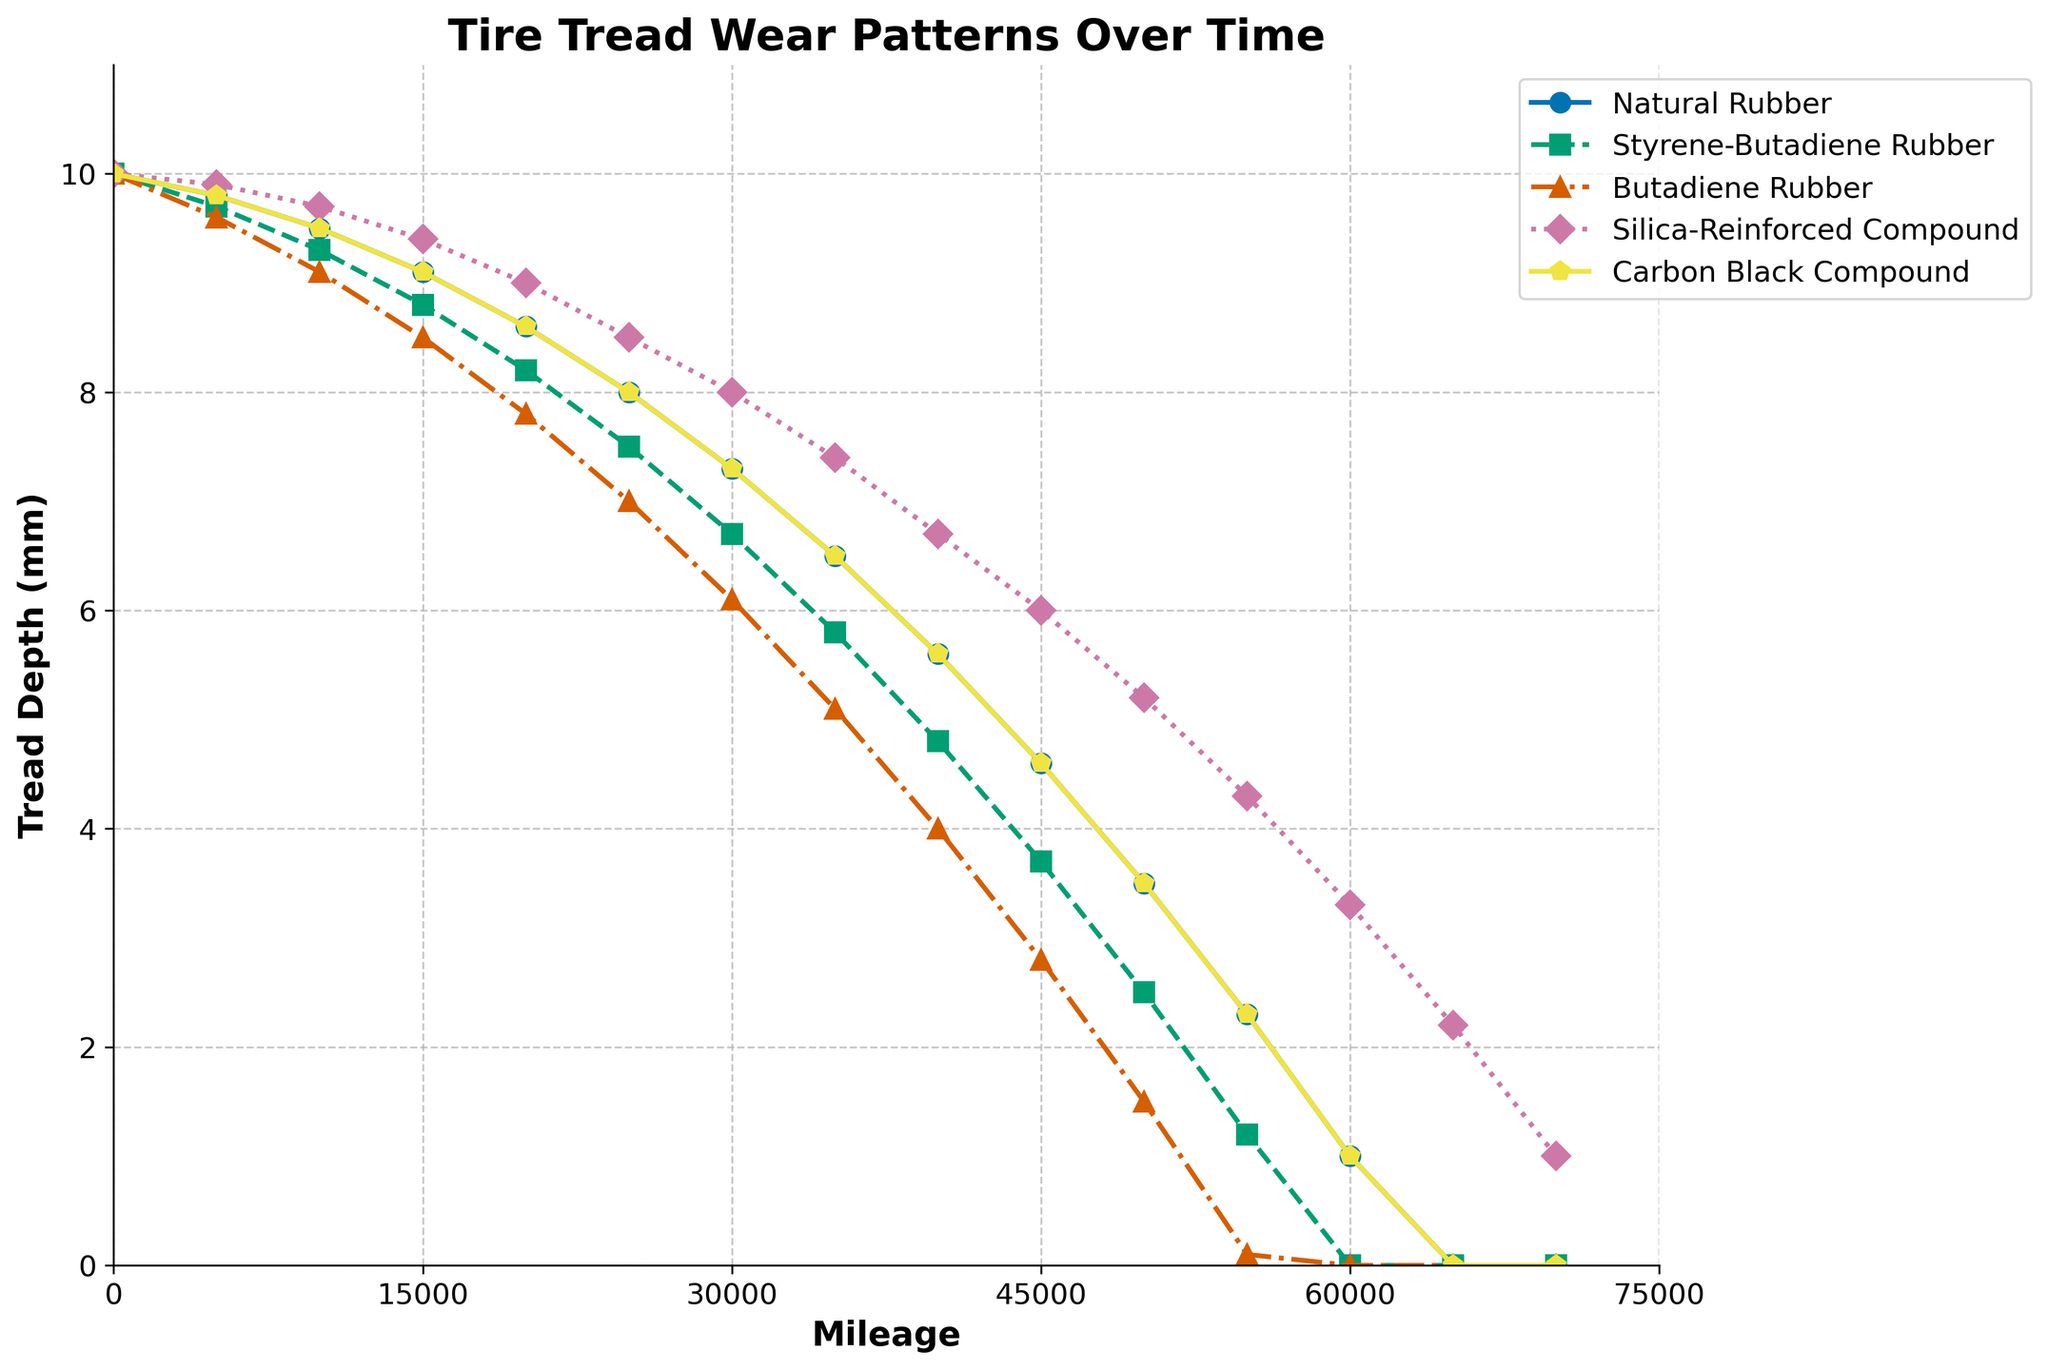Which tire compound retains the most tread depth after 50,000 miles? The tire compound with the most tread depth at 50,000 miles is the one with the highest vertical position at this mileage on the graph. Silica-Reinforced Compound has a tread depth of 5.2 mm, which is higher than all other compounds.
Answer: Silica-Reinforced Compound What is the average tread depth of Butadiene Rubber and Carbon Black Compound at 20,000 miles? The tread depths at 20,000 miles are 7.8 mm for Butadiene Rubber and 8.6 mm for Carbon Black Compound. The average is calculated by (7.8 + 8.6) / 2.
Answer: 8.2 mm Which compound shows the fastest tread wear rate between 0 and 20,000 miles? To determine the fastest wear rate, we compare the decrease in tread depth for each compound over the 20,000 miles. Butadiene Rubber decreases from 10.0 to 7.8 mm (2.2 mm loss), the greatest among the compounds.
Answer: Butadiene Rubber At what mileage does the tread depth of Styrene-Butadiene Rubber drop below 5 mm? We look at the data points for Styrene-Butadiene Rubber and find the mileage where it first drops below 5 mm. This occurs between 35,000 and 40,000 miles.
Answer: 40,000 miles At 40,000 miles, which tire compound has exactly 6.7 mm tread depth? By examining the graph at the 40,000-mile mark, we see that Silica-Reinforced Compound has a tread depth of exactly 6.7 mm.
Answer: Silica-Reinforced Compound Compare the tread loss of Natural Rubber and Carbon Black Compound from 0 to 60,000 miles. Which one loses more? The initial and final tread depths for Natural Rubber are 10.0 mm and 1.0 mm, resulting in a loss of 9.0 mm. For Carbon Black Compound, the values are 10.0 mm and 1.0 mm, also resulting in a loss of 9.0 mm.
Answer: Both lose 9.0 mm What is the total difference in tread depth between Natural Rubber and Styrene-Butadiene Rubber after 55000 miles? The tread depth of Natural Rubber is 2.3 mm, and for Styrene-Butadiene Rubber, it is 1.2 mm at 55,000 miles. The total difference is 2.3 - 1.2 mm.
Answer: 1.1 mm Which tire compound has the steepest decline in tread depth between 25,000 and 45,000 miles? By looking at the slopes of the lines between these mileages, Styrene-Butadiene Rubber shows the steepest decline, moving from 7.5 mm to 3.7 mm for a loss of 3.8 mm.
Answer: Styrene-Butadiene Rubber Is there any compound that completely wears out before 60,000 miles? By checking the graph, both Styrene-Butadiene Rubber and Butadiene Rubber reach a tread depth of 0 before 60,000 miles.
Answer: Yes, Styrene-Butadiene Rubber and Butadiene Rubber 